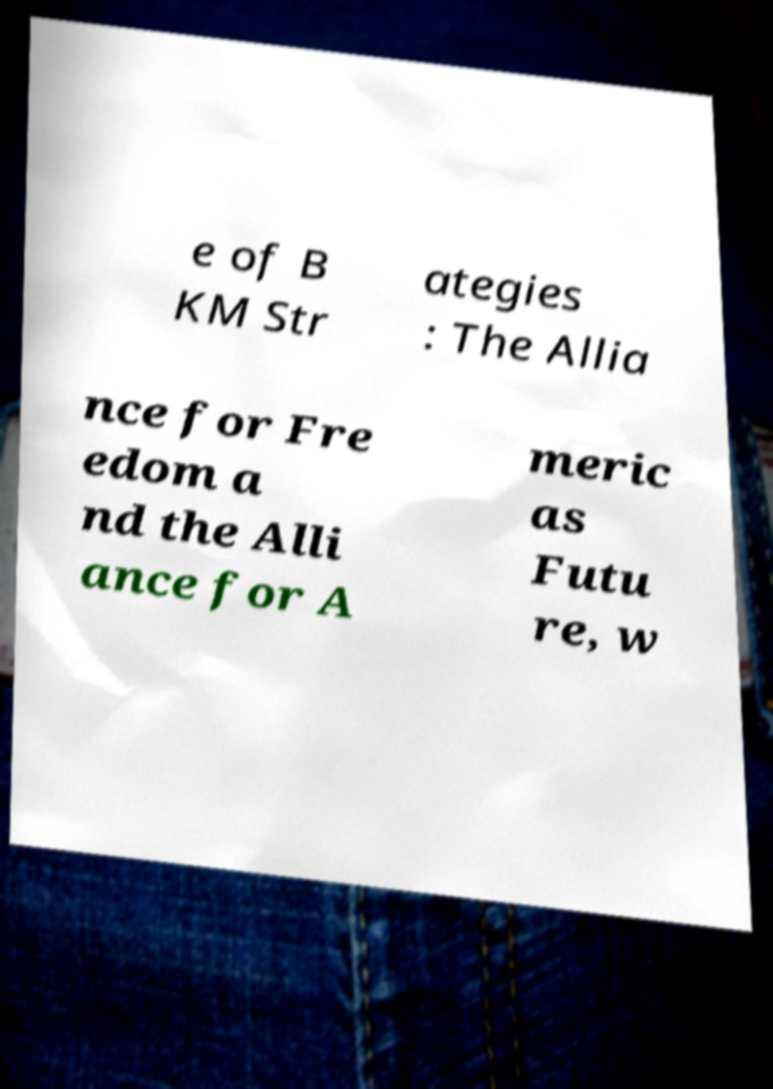For documentation purposes, I need the text within this image transcribed. Could you provide that? e of B KM Str ategies : The Allia nce for Fre edom a nd the Alli ance for A meric as Futu re, w 